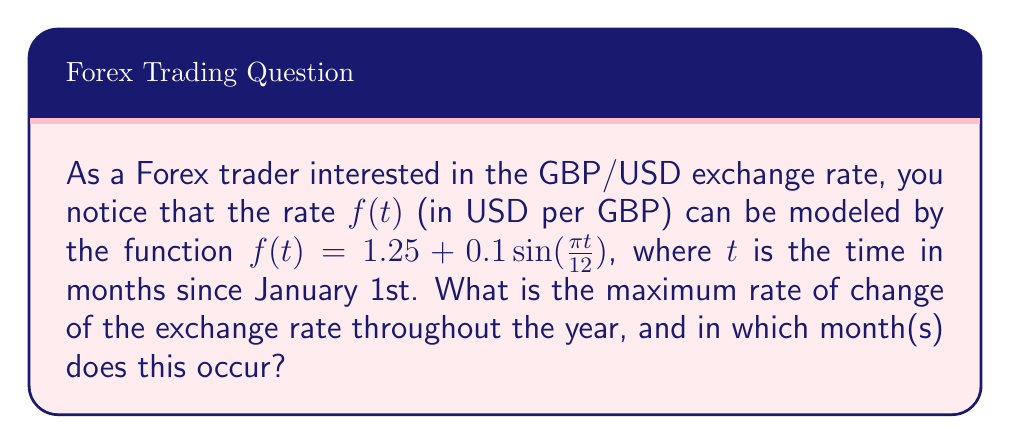Teach me how to tackle this problem. To solve this problem, we need to follow these steps:

1) First, we need to find the derivative of the exchange rate function $f(t)$. This will give us the rate of change at any given time.

   $$f'(t) = 0.1 \cdot \frac{\pi}{12} \cos(\frac{\pi t}{12})$$

2) The maximum rate of change will occur when $|f'(t)|$ is at its maximum. The absolute value of cosine has a maximum of 1, which occurs when its argument is a multiple of $\pi$.

3) So, we need to solve:

   $$\frac{\pi t}{12} = n\pi$$
   
   where $n$ is an integer.

4) Solving for $t$:

   $$t = 12n$$

   This means the maximum rate of change occurs every 12 months, or once a year.

5) To find the actual maximum rate of change, we evaluate $|f'(t)|$ at these points:

   $$|f'(12n)| = |\frac{0.1\pi}{12}| \approx 0.0262$$

6) To determine which month this occurs, we need to consider that $t=0$ corresponds to January 1st. The maximum positive rate of change occurs when $n$ is even (0, 2, 4, ...), which corresponds to January. The maximum negative rate of change occurs when $n$ is odd (1, 3, 5, ...), which corresponds to July.
Answer: The maximum rate of change of the exchange rate is approximately $0.0262$ USD per GBP per month. This occurs twice a year: a maximum increase in January and a maximum decrease in July. 